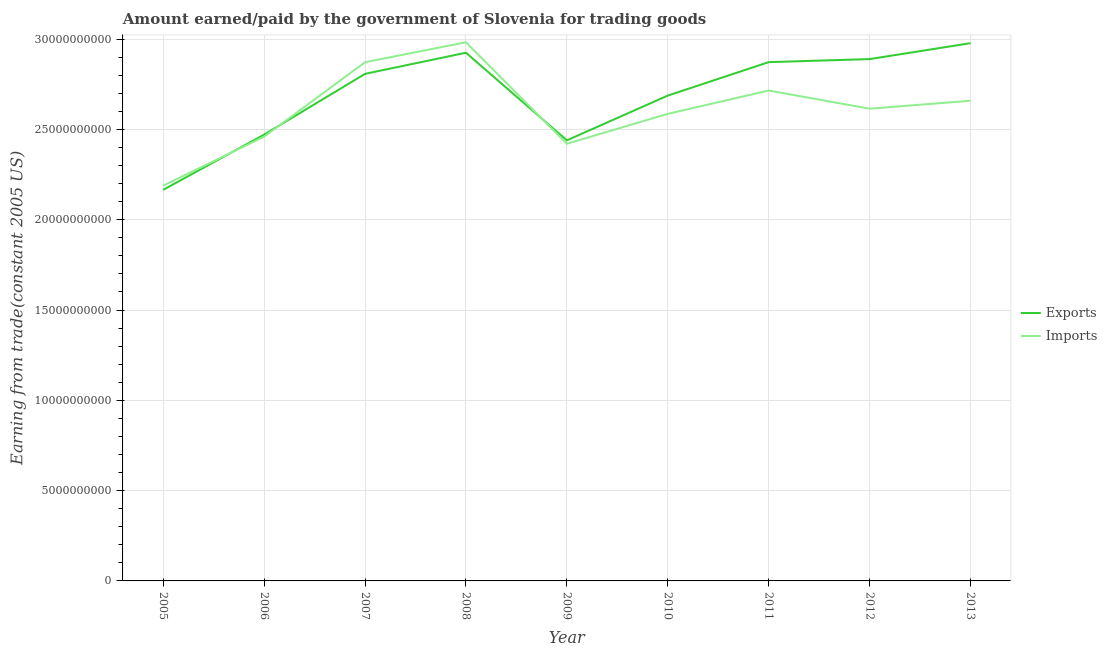What is the amount earned from exports in 2012?
Make the answer very short. 2.89e+1. Across all years, what is the maximum amount earned from exports?
Your response must be concise. 2.98e+1. Across all years, what is the minimum amount paid for imports?
Your response must be concise. 2.19e+1. In which year was the amount paid for imports maximum?
Give a very brief answer. 2008. What is the total amount earned from exports in the graph?
Keep it short and to the point. 2.42e+11. What is the difference between the amount paid for imports in 2007 and that in 2010?
Make the answer very short. 2.86e+09. What is the difference between the amount paid for imports in 2006 and the amount earned from exports in 2008?
Provide a short and direct response. -4.65e+09. What is the average amount paid for imports per year?
Keep it short and to the point. 2.61e+1. In the year 2012, what is the difference between the amount paid for imports and amount earned from exports?
Keep it short and to the point. -2.75e+09. In how many years, is the amount earned from exports greater than 8000000000 US$?
Give a very brief answer. 9. What is the ratio of the amount paid for imports in 2008 to that in 2009?
Your answer should be compact. 1.23. Is the difference between the amount earned from exports in 2008 and 2011 greater than the difference between the amount paid for imports in 2008 and 2011?
Offer a very short reply. No. What is the difference between the highest and the second highest amount earned from exports?
Your response must be concise. 5.29e+08. What is the difference between the highest and the lowest amount paid for imports?
Your answer should be very brief. 7.94e+09. In how many years, is the amount earned from exports greater than the average amount earned from exports taken over all years?
Your response must be concise. 5. Is the sum of the amount paid for imports in 2009 and 2012 greater than the maximum amount earned from exports across all years?
Your response must be concise. Yes. Is the amount paid for imports strictly greater than the amount earned from exports over the years?
Keep it short and to the point. No. How many lines are there?
Provide a short and direct response. 2. How many years are there in the graph?
Offer a terse response. 9. What is the difference between two consecutive major ticks on the Y-axis?
Ensure brevity in your answer.  5.00e+09. Does the graph contain grids?
Provide a short and direct response. Yes. What is the title of the graph?
Offer a terse response. Amount earned/paid by the government of Slovenia for trading goods. What is the label or title of the X-axis?
Keep it short and to the point. Year. What is the label or title of the Y-axis?
Ensure brevity in your answer.  Earning from trade(constant 2005 US). What is the Earning from trade(constant 2005 US) of Exports in 2005?
Make the answer very short. 2.17e+1. What is the Earning from trade(constant 2005 US) in Imports in 2005?
Ensure brevity in your answer.  2.19e+1. What is the Earning from trade(constant 2005 US) of Exports in 2006?
Give a very brief answer. 2.47e+1. What is the Earning from trade(constant 2005 US) of Imports in 2006?
Offer a terse response. 2.46e+1. What is the Earning from trade(constant 2005 US) in Exports in 2007?
Make the answer very short. 2.81e+1. What is the Earning from trade(constant 2005 US) in Imports in 2007?
Give a very brief answer. 2.87e+1. What is the Earning from trade(constant 2005 US) in Exports in 2008?
Make the answer very short. 2.92e+1. What is the Earning from trade(constant 2005 US) of Imports in 2008?
Provide a short and direct response. 2.98e+1. What is the Earning from trade(constant 2005 US) of Exports in 2009?
Your answer should be very brief. 2.44e+1. What is the Earning from trade(constant 2005 US) of Imports in 2009?
Your answer should be compact. 2.42e+1. What is the Earning from trade(constant 2005 US) in Exports in 2010?
Offer a terse response. 2.69e+1. What is the Earning from trade(constant 2005 US) of Imports in 2010?
Offer a terse response. 2.59e+1. What is the Earning from trade(constant 2005 US) in Exports in 2011?
Your answer should be compact. 2.87e+1. What is the Earning from trade(constant 2005 US) of Imports in 2011?
Ensure brevity in your answer.  2.72e+1. What is the Earning from trade(constant 2005 US) in Exports in 2012?
Offer a very short reply. 2.89e+1. What is the Earning from trade(constant 2005 US) in Imports in 2012?
Offer a very short reply. 2.61e+1. What is the Earning from trade(constant 2005 US) in Exports in 2013?
Your answer should be very brief. 2.98e+1. What is the Earning from trade(constant 2005 US) of Imports in 2013?
Offer a very short reply. 2.66e+1. Across all years, what is the maximum Earning from trade(constant 2005 US) of Exports?
Your response must be concise. 2.98e+1. Across all years, what is the maximum Earning from trade(constant 2005 US) in Imports?
Give a very brief answer. 2.98e+1. Across all years, what is the minimum Earning from trade(constant 2005 US) in Exports?
Keep it short and to the point. 2.17e+1. Across all years, what is the minimum Earning from trade(constant 2005 US) of Imports?
Provide a succinct answer. 2.19e+1. What is the total Earning from trade(constant 2005 US) of Exports in the graph?
Your answer should be very brief. 2.42e+11. What is the total Earning from trade(constant 2005 US) in Imports in the graph?
Provide a succinct answer. 2.35e+11. What is the difference between the Earning from trade(constant 2005 US) of Exports in 2005 and that in 2006?
Ensure brevity in your answer.  -3.06e+09. What is the difference between the Earning from trade(constant 2005 US) in Imports in 2005 and that in 2006?
Offer a terse response. -2.71e+09. What is the difference between the Earning from trade(constant 2005 US) in Exports in 2005 and that in 2007?
Your answer should be very brief. -6.42e+09. What is the difference between the Earning from trade(constant 2005 US) in Imports in 2005 and that in 2007?
Your response must be concise. -6.83e+09. What is the difference between the Earning from trade(constant 2005 US) of Exports in 2005 and that in 2008?
Your answer should be very brief. -7.59e+09. What is the difference between the Earning from trade(constant 2005 US) of Imports in 2005 and that in 2008?
Keep it short and to the point. -7.94e+09. What is the difference between the Earning from trade(constant 2005 US) of Exports in 2005 and that in 2009?
Provide a short and direct response. -2.74e+09. What is the difference between the Earning from trade(constant 2005 US) of Imports in 2005 and that in 2009?
Make the answer very short. -2.32e+09. What is the difference between the Earning from trade(constant 2005 US) in Exports in 2005 and that in 2010?
Provide a succinct answer. -5.22e+09. What is the difference between the Earning from trade(constant 2005 US) in Imports in 2005 and that in 2010?
Offer a very short reply. -3.97e+09. What is the difference between the Earning from trade(constant 2005 US) of Exports in 2005 and that in 2011?
Offer a terse response. -7.07e+09. What is the difference between the Earning from trade(constant 2005 US) in Imports in 2005 and that in 2011?
Your answer should be compact. -5.27e+09. What is the difference between the Earning from trade(constant 2005 US) in Exports in 2005 and that in 2012?
Your response must be concise. -7.24e+09. What is the difference between the Earning from trade(constant 2005 US) of Imports in 2005 and that in 2012?
Keep it short and to the point. -4.26e+09. What is the difference between the Earning from trade(constant 2005 US) of Exports in 2005 and that in 2013?
Provide a succinct answer. -8.12e+09. What is the difference between the Earning from trade(constant 2005 US) of Imports in 2005 and that in 2013?
Ensure brevity in your answer.  -4.70e+09. What is the difference between the Earning from trade(constant 2005 US) in Exports in 2006 and that in 2007?
Your response must be concise. -3.36e+09. What is the difference between the Earning from trade(constant 2005 US) in Imports in 2006 and that in 2007?
Offer a terse response. -4.12e+09. What is the difference between the Earning from trade(constant 2005 US) in Exports in 2006 and that in 2008?
Keep it short and to the point. -4.53e+09. What is the difference between the Earning from trade(constant 2005 US) in Imports in 2006 and that in 2008?
Provide a succinct answer. -5.23e+09. What is the difference between the Earning from trade(constant 2005 US) in Exports in 2006 and that in 2009?
Provide a short and direct response. 3.18e+08. What is the difference between the Earning from trade(constant 2005 US) of Imports in 2006 and that in 2009?
Give a very brief answer. 3.92e+08. What is the difference between the Earning from trade(constant 2005 US) in Exports in 2006 and that in 2010?
Ensure brevity in your answer.  -2.16e+09. What is the difference between the Earning from trade(constant 2005 US) in Imports in 2006 and that in 2010?
Give a very brief answer. -1.26e+09. What is the difference between the Earning from trade(constant 2005 US) of Exports in 2006 and that in 2011?
Your response must be concise. -4.01e+09. What is the difference between the Earning from trade(constant 2005 US) in Imports in 2006 and that in 2011?
Your answer should be very brief. -2.56e+09. What is the difference between the Earning from trade(constant 2005 US) of Exports in 2006 and that in 2012?
Provide a short and direct response. -4.18e+09. What is the difference between the Earning from trade(constant 2005 US) in Imports in 2006 and that in 2012?
Make the answer very short. -1.55e+09. What is the difference between the Earning from trade(constant 2005 US) in Exports in 2006 and that in 2013?
Provide a short and direct response. -5.06e+09. What is the difference between the Earning from trade(constant 2005 US) in Imports in 2006 and that in 2013?
Ensure brevity in your answer.  -1.99e+09. What is the difference between the Earning from trade(constant 2005 US) of Exports in 2007 and that in 2008?
Give a very brief answer. -1.17e+09. What is the difference between the Earning from trade(constant 2005 US) in Imports in 2007 and that in 2008?
Offer a terse response. -1.11e+09. What is the difference between the Earning from trade(constant 2005 US) in Exports in 2007 and that in 2009?
Your answer should be compact. 3.68e+09. What is the difference between the Earning from trade(constant 2005 US) in Imports in 2007 and that in 2009?
Provide a succinct answer. 4.51e+09. What is the difference between the Earning from trade(constant 2005 US) of Exports in 2007 and that in 2010?
Ensure brevity in your answer.  1.20e+09. What is the difference between the Earning from trade(constant 2005 US) of Imports in 2007 and that in 2010?
Give a very brief answer. 2.86e+09. What is the difference between the Earning from trade(constant 2005 US) in Exports in 2007 and that in 2011?
Make the answer very short. -6.49e+08. What is the difference between the Earning from trade(constant 2005 US) in Imports in 2007 and that in 2011?
Make the answer very short. 1.57e+09. What is the difference between the Earning from trade(constant 2005 US) of Exports in 2007 and that in 2012?
Your answer should be compact. -8.17e+08. What is the difference between the Earning from trade(constant 2005 US) of Imports in 2007 and that in 2012?
Make the answer very short. 2.57e+09. What is the difference between the Earning from trade(constant 2005 US) of Exports in 2007 and that in 2013?
Keep it short and to the point. -1.70e+09. What is the difference between the Earning from trade(constant 2005 US) of Imports in 2007 and that in 2013?
Keep it short and to the point. 2.13e+09. What is the difference between the Earning from trade(constant 2005 US) in Exports in 2008 and that in 2009?
Your answer should be compact. 4.85e+09. What is the difference between the Earning from trade(constant 2005 US) of Imports in 2008 and that in 2009?
Offer a very short reply. 5.62e+09. What is the difference between the Earning from trade(constant 2005 US) in Exports in 2008 and that in 2010?
Offer a very short reply. 2.37e+09. What is the difference between the Earning from trade(constant 2005 US) in Imports in 2008 and that in 2010?
Offer a very short reply. 3.96e+09. What is the difference between the Earning from trade(constant 2005 US) in Exports in 2008 and that in 2011?
Provide a succinct answer. 5.21e+08. What is the difference between the Earning from trade(constant 2005 US) in Imports in 2008 and that in 2011?
Provide a short and direct response. 2.67e+09. What is the difference between the Earning from trade(constant 2005 US) in Exports in 2008 and that in 2012?
Keep it short and to the point. 3.53e+08. What is the difference between the Earning from trade(constant 2005 US) in Imports in 2008 and that in 2012?
Give a very brief answer. 3.68e+09. What is the difference between the Earning from trade(constant 2005 US) of Exports in 2008 and that in 2013?
Make the answer very short. -5.29e+08. What is the difference between the Earning from trade(constant 2005 US) in Imports in 2008 and that in 2013?
Your response must be concise. 3.24e+09. What is the difference between the Earning from trade(constant 2005 US) in Exports in 2009 and that in 2010?
Keep it short and to the point. -2.48e+09. What is the difference between the Earning from trade(constant 2005 US) of Imports in 2009 and that in 2010?
Your answer should be very brief. -1.66e+09. What is the difference between the Earning from trade(constant 2005 US) of Exports in 2009 and that in 2011?
Keep it short and to the point. -4.33e+09. What is the difference between the Earning from trade(constant 2005 US) of Imports in 2009 and that in 2011?
Provide a succinct answer. -2.95e+09. What is the difference between the Earning from trade(constant 2005 US) of Exports in 2009 and that in 2012?
Your answer should be very brief. -4.50e+09. What is the difference between the Earning from trade(constant 2005 US) in Imports in 2009 and that in 2012?
Offer a terse response. -1.94e+09. What is the difference between the Earning from trade(constant 2005 US) in Exports in 2009 and that in 2013?
Your answer should be compact. -5.38e+09. What is the difference between the Earning from trade(constant 2005 US) in Imports in 2009 and that in 2013?
Ensure brevity in your answer.  -2.38e+09. What is the difference between the Earning from trade(constant 2005 US) in Exports in 2010 and that in 2011?
Keep it short and to the point. -1.85e+09. What is the difference between the Earning from trade(constant 2005 US) in Imports in 2010 and that in 2011?
Provide a short and direct response. -1.29e+09. What is the difference between the Earning from trade(constant 2005 US) in Exports in 2010 and that in 2012?
Provide a succinct answer. -2.02e+09. What is the difference between the Earning from trade(constant 2005 US) of Imports in 2010 and that in 2012?
Provide a succinct answer. -2.86e+08. What is the difference between the Earning from trade(constant 2005 US) of Exports in 2010 and that in 2013?
Make the answer very short. -2.90e+09. What is the difference between the Earning from trade(constant 2005 US) of Imports in 2010 and that in 2013?
Give a very brief answer. -7.26e+08. What is the difference between the Earning from trade(constant 2005 US) in Exports in 2011 and that in 2012?
Provide a short and direct response. -1.68e+08. What is the difference between the Earning from trade(constant 2005 US) in Imports in 2011 and that in 2012?
Ensure brevity in your answer.  1.01e+09. What is the difference between the Earning from trade(constant 2005 US) of Exports in 2011 and that in 2013?
Give a very brief answer. -1.05e+09. What is the difference between the Earning from trade(constant 2005 US) in Imports in 2011 and that in 2013?
Provide a succinct answer. 5.66e+08. What is the difference between the Earning from trade(constant 2005 US) of Exports in 2012 and that in 2013?
Ensure brevity in your answer.  -8.82e+08. What is the difference between the Earning from trade(constant 2005 US) in Imports in 2012 and that in 2013?
Make the answer very short. -4.40e+08. What is the difference between the Earning from trade(constant 2005 US) in Exports in 2005 and the Earning from trade(constant 2005 US) in Imports in 2006?
Make the answer very short. -2.94e+09. What is the difference between the Earning from trade(constant 2005 US) in Exports in 2005 and the Earning from trade(constant 2005 US) in Imports in 2007?
Your response must be concise. -7.07e+09. What is the difference between the Earning from trade(constant 2005 US) of Exports in 2005 and the Earning from trade(constant 2005 US) of Imports in 2008?
Make the answer very short. -8.17e+09. What is the difference between the Earning from trade(constant 2005 US) in Exports in 2005 and the Earning from trade(constant 2005 US) in Imports in 2009?
Make the answer very short. -2.55e+09. What is the difference between the Earning from trade(constant 2005 US) of Exports in 2005 and the Earning from trade(constant 2005 US) of Imports in 2010?
Keep it short and to the point. -4.21e+09. What is the difference between the Earning from trade(constant 2005 US) of Exports in 2005 and the Earning from trade(constant 2005 US) of Imports in 2011?
Give a very brief answer. -5.50e+09. What is the difference between the Earning from trade(constant 2005 US) in Exports in 2005 and the Earning from trade(constant 2005 US) in Imports in 2012?
Make the answer very short. -4.49e+09. What is the difference between the Earning from trade(constant 2005 US) of Exports in 2005 and the Earning from trade(constant 2005 US) of Imports in 2013?
Make the answer very short. -4.93e+09. What is the difference between the Earning from trade(constant 2005 US) in Exports in 2006 and the Earning from trade(constant 2005 US) in Imports in 2007?
Ensure brevity in your answer.  -4.01e+09. What is the difference between the Earning from trade(constant 2005 US) in Exports in 2006 and the Earning from trade(constant 2005 US) in Imports in 2008?
Keep it short and to the point. -5.11e+09. What is the difference between the Earning from trade(constant 2005 US) in Exports in 2006 and the Earning from trade(constant 2005 US) in Imports in 2009?
Provide a succinct answer. 5.07e+08. What is the difference between the Earning from trade(constant 2005 US) in Exports in 2006 and the Earning from trade(constant 2005 US) in Imports in 2010?
Your answer should be compact. -1.15e+09. What is the difference between the Earning from trade(constant 2005 US) in Exports in 2006 and the Earning from trade(constant 2005 US) in Imports in 2011?
Make the answer very short. -2.44e+09. What is the difference between the Earning from trade(constant 2005 US) in Exports in 2006 and the Earning from trade(constant 2005 US) in Imports in 2012?
Your response must be concise. -1.43e+09. What is the difference between the Earning from trade(constant 2005 US) in Exports in 2006 and the Earning from trade(constant 2005 US) in Imports in 2013?
Keep it short and to the point. -1.87e+09. What is the difference between the Earning from trade(constant 2005 US) of Exports in 2007 and the Earning from trade(constant 2005 US) of Imports in 2008?
Offer a very short reply. -1.75e+09. What is the difference between the Earning from trade(constant 2005 US) of Exports in 2007 and the Earning from trade(constant 2005 US) of Imports in 2009?
Give a very brief answer. 3.87e+09. What is the difference between the Earning from trade(constant 2005 US) in Exports in 2007 and the Earning from trade(constant 2005 US) in Imports in 2010?
Your answer should be compact. 2.22e+09. What is the difference between the Earning from trade(constant 2005 US) in Exports in 2007 and the Earning from trade(constant 2005 US) in Imports in 2011?
Offer a very short reply. 9.23e+08. What is the difference between the Earning from trade(constant 2005 US) in Exports in 2007 and the Earning from trade(constant 2005 US) in Imports in 2012?
Offer a terse response. 1.93e+09. What is the difference between the Earning from trade(constant 2005 US) of Exports in 2007 and the Earning from trade(constant 2005 US) of Imports in 2013?
Ensure brevity in your answer.  1.49e+09. What is the difference between the Earning from trade(constant 2005 US) in Exports in 2008 and the Earning from trade(constant 2005 US) in Imports in 2009?
Your answer should be compact. 5.04e+09. What is the difference between the Earning from trade(constant 2005 US) of Exports in 2008 and the Earning from trade(constant 2005 US) of Imports in 2010?
Your answer should be compact. 3.39e+09. What is the difference between the Earning from trade(constant 2005 US) of Exports in 2008 and the Earning from trade(constant 2005 US) of Imports in 2011?
Make the answer very short. 2.09e+09. What is the difference between the Earning from trade(constant 2005 US) of Exports in 2008 and the Earning from trade(constant 2005 US) of Imports in 2012?
Provide a short and direct response. 3.10e+09. What is the difference between the Earning from trade(constant 2005 US) in Exports in 2008 and the Earning from trade(constant 2005 US) in Imports in 2013?
Your answer should be very brief. 2.66e+09. What is the difference between the Earning from trade(constant 2005 US) of Exports in 2009 and the Earning from trade(constant 2005 US) of Imports in 2010?
Your response must be concise. -1.47e+09. What is the difference between the Earning from trade(constant 2005 US) of Exports in 2009 and the Earning from trade(constant 2005 US) of Imports in 2011?
Your response must be concise. -2.76e+09. What is the difference between the Earning from trade(constant 2005 US) in Exports in 2009 and the Earning from trade(constant 2005 US) in Imports in 2012?
Your answer should be very brief. -1.75e+09. What is the difference between the Earning from trade(constant 2005 US) of Exports in 2009 and the Earning from trade(constant 2005 US) of Imports in 2013?
Make the answer very short. -2.19e+09. What is the difference between the Earning from trade(constant 2005 US) in Exports in 2010 and the Earning from trade(constant 2005 US) in Imports in 2011?
Keep it short and to the point. -2.81e+08. What is the difference between the Earning from trade(constant 2005 US) in Exports in 2010 and the Earning from trade(constant 2005 US) in Imports in 2012?
Provide a short and direct response. 7.25e+08. What is the difference between the Earning from trade(constant 2005 US) in Exports in 2010 and the Earning from trade(constant 2005 US) in Imports in 2013?
Provide a succinct answer. 2.85e+08. What is the difference between the Earning from trade(constant 2005 US) of Exports in 2011 and the Earning from trade(constant 2005 US) of Imports in 2012?
Keep it short and to the point. 2.58e+09. What is the difference between the Earning from trade(constant 2005 US) in Exports in 2011 and the Earning from trade(constant 2005 US) in Imports in 2013?
Keep it short and to the point. 2.14e+09. What is the difference between the Earning from trade(constant 2005 US) of Exports in 2012 and the Earning from trade(constant 2005 US) of Imports in 2013?
Offer a very short reply. 2.31e+09. What is the average Earning from trade(constant 2005 US) in Exports per year?
Make the answer very short. 2.69e+1. What is the average Earning from trade(constant 2005 US) in Imports per year?
Your response must be concise. 2.61e+1. In the year 2005, what is the difference between the Earning from trade(constant 2005 US) in Exports and Earning from trade(constant 2005 US) in Imports?
Offer a very short reply. -2.32e+08. In the year 2006, what is the difference between the Earning from trade(constant 2005 US) of Exports and Earning from trade(constant 2005 US) of Imports?
Your answer should be compact. 1.15e+08. In the year 2007, what is the difference between the Earning from trade(constant 2005 US) of Exports and Earning from trade(constant 2005 US) of Imports?
Keep it short and to the point. -6.44e+08. In the year 2008, what is the difference between the Earning from trade(constant 2005 US) of Exports and Earning from trade(constant 2005 US) of Imports?
Provide a short and direct response. -5.80e+08. In the year 2009, what is the difference between the Earning from trade(constant 2005 US) in Exports and Earning from trade(constant 2005 US) in Imports?
Keep it short and to the point. 1.89e+08. In the year 2010, what is the difference between the Earning from trade(constant 2005 US) in Exports and Earning from trade(constant 2005 US) in Imports?
Give a very brief answer. 1.01e+09. In the year 2011, what is the difference between the Earning from trade(constant 2005 US) in Exports and Earning from trade(constant 2005 US) in Imports?
Keep it short and to the point. 1.57e+09. In the year 2012, what is the difference between the Earning from trade(constant 2005 US) of Exports and Earning from trade(constant 2005 US) of Imports?
Your answer should be very brief. 2.75e+09. In the year 2013, what is the difference between the Earning from trade(constant 2005 US) of Exports and Earning from trade(constant 2005 US) of Imports?
Your response must be concise. 3.19e+09. What is the ratio of the Earning from trade(constant 2005 US) of Exports in 2005 to that in 2006?
Offer a very short reply. 0.88. What is the ratio of the Earning from trade(constant 2005 US) in Imports in 2005 to that in 2006?
Provide a short and direct response. 0.89. What is the ratio of the Earning from trade(constant 2005 US) in Exports in 2005 to that in 2007?
Keep it short and to the point. 0.77. What is the ratio of the Earning from trade(constant 2005 US) in Imports in 2005 to that in 2007?
Provide a short and direct response. 0.76. What is the ratio of the Earning from trade(constant 2005 US) in Exports in 2005 to that in 2008?
Your answer should be compact. 0.74. What is the ratio of the Earning from trade(constant 2005 US) of Imports in 2005 to that in 2008?
Your answer should be very brief. 0.73. What is the ratio of the Earning from trade(constant 2005 US) in Exports in 2005 to that in 2009?
Your answer should be compact. 0.89. What is the ratio of the Earning from trade(constant 2005 US) in Imports in 2005 to that in 2009?
Your answer should be very brief. 0.9. What is the ratio of the Earning from trade(constant 2005 US) in Exports in 2005 to that in 2010?
Make the answer very short. 0.81. What is the ratio of the Earning from trade(constant 2005 US) of Imports in 2005 to that in 2010?
Provide a succinct answer. 0.85. What is the ratio of the Earning from trade(constant 2005 US) of Exports in 2005 to that in 2011?
Make the answer very short. 0.75. What is the ratio of the Earning from trade(constant 2005 US) in Imports in 2005 to that in 2011?
Make the answer very short. 0.81. What is the ratio of the Earning from trade(constant 2005 US) in Exports in 2005 to that in 2012?
Keep it short and to the point. 0.75. What is the ratio of the Earning from trade(constant 2005 US) in Imports in 2005 to that in 2012?
Offer a very short reply. 0.84. What is the ratio of the Earning from trade(constant 2005 US) in Exports in 2005 to that in 2013?
Your answer should be compact. 0.73. What is the ratio of the Earning from trade(constant 2005 US) of Imports in 2005 to that in 2013?
Make the answer very short. 0.82. What is the ratio of the Earning from trade(constant 2005 US) in Exports in 2006 to that in 2007?
Keep it short and to the point. 0.88. What is the ratio of the Earning from trade(constant 2005 US) in Imports in 2006 to that in 2007?
Offer a terse response. 0.86. What is the ratio of the Earning from trade(constant 2005 US) in Exports in 2006 to that in 2008?
Keep it short and to the point. 0.84. What is the ratio of the Earning from trade(constant 2005 US) of Imports in 2006 to that in 2008?
Provide a succinct answer. 0.82. What is the ratio of the Earning from trade(constant 2005 US) in Exports in 2006 to that in 2009?
Make the answer very short. 1.01. What is the ratio of the Earning from trade(constant 2005 US) in Imports in 2006 to that in 2009?
Your response must be concise. 1.02. What is the ratio of the Earning from trade(constant 2005 US) in Exports in 2006 to that in 2010?
Provide a short and direct response. 0.92. What is the ratio of the Earning from trade(constant 2005 US) of Imports in 2006 to that in 2010?
Your answer should be very brief. 0.95. What is the ratio of the Earning from trade(constant 2005 US) in Exports in 2006 to that in 2011?
Provide a short and direct response. 0.86. What is the ratio of the Earning from trade(constant 2005 US) in Imports in 2006 to that in 2011?
Provide a short and direct response. 0.91. What is the ratio of the Earning from trade(constant 2005 US) in Exports in 2006 to that in 2012?
Provide a succinct answer. 0.86. What is the ratio of the Earning from trade(constant 2005 US) in Imports in 2006 to that in 2012?
Offer a terse response. 0.94. What is the ratio of the Earning from trade(constant 2005 US) in Exports in 2006 to that in 2013?
Your response must be concise. 0.83. What is the ratio of the Earning from trade(constant 2005 US) in Imports in 2006 to that in 2013?
Provide a succinct answer. 0.93. What is the ratio of the Earning from trade(constant 2005 US) in Exports in 2007 to that in 2008?
Offer a very short reply. 0.96. What is the ratio of the Earning from trade(constant 2005 US) in Imports in 2007 to that in 2008?
Your answer should be very brief. 0.96. What is the ratio of the Earning from trade(constant 2005 US) of Exports in 2007 to that in 2009?
Keep it short and to the point. 1.15. What is the ratio of the Earning from trade(constant 2005 US) of Imports in 2007 to that in 2009?
Ensure brevity in your answer.  1.19. What is the ratio of the Earning from trade(constant 2005 US) in Exports in 2007 to that in 2010?
Keep it short and to the point. 1.04. What is the ratio of the Earning from trade(constant 2005 US) of Imports in 2007 to that in 2010?
Give a very brief answer. 1.11. What is the ratio of the Earning from trade(constant 2005 US) of Exports in 2007 to that in 2011?
Offer a terse response. 0.98. What is the ratio of the Earning from trade(constant 2005 US) of Imports in 2007 to that in 2011?
Make the answer very short. 1.06. What is the ratio of the Earning from trade(constant 2005 US) of Exports in 2007 to that in 2012?
Make the answer very short. 0.97. What is the ratio of the Earning from trade(constant 2005 US) of Imports in 2007 to that in 2012?
Give a very brief answer. 1.1. What is the ratio of the Earning from trade(constant 2005 US) in Exports in 2007 to that in 2013?
Ensure brevity in your answer.  0.94. What is the ratio of the Earning from trade(constant 2005 US) of Imports in 2007 to that in 2013?
Give a very brief answer. 1.08. What is the ratio of the Earning from trade(constant 2005 US) in Exports in 2008 to that in 2009?
Offer a terse response. 1.2. What is the ratio of the Earning from trade(constant 2005 US) of Imports in 2008 to that in 2009?
Your answer should be compact. 1.23. What is the ratio of the Earning from trade(constant 2005 US) of Exports in 2008 to that in 2010?
Offer a very short reply. 1.09. What is the ratio of the Earning from trade(constant 2005 US) of Imports in 2008 to that in 2010?
Your response must be concise. 1.15. What is the ratio of the Earning from trade(constant 2005 US) of Exports in 2008 to that in 2011?
Your answer should be compact. 1.02. What is the ratio of the Earning from trade(constant 2005 US) of Imports in 2008 to that in 2011?
Offer a very short reply. 1.1. What is the ratio of the Earning from trade(constant 2005 US) of Exports in 2008 to that in 2012?
Your answer should be compact. 1.01. What is the ratio of the Earning from trade(constant 2005 US) of Imports in 2008 to that in 2012?
Provide a succinct answer. 1.14. What is the ratio of the Earning from trade(constant 2005 US) in Exports in 2008 to that in 2013?
Your answer should be very brief. 0.98. What is the ratio of the Earning from trade(constant 2005 US) of Imports in 2008 to that in 2013?
Keep it short and to the point. 1.12. What is the ratio of the Earning from trade(constant 2005 US) of Exports in 2009 to that in 2010?
Make the answer very short. 0.91. What is the ratio of the Earning from trade(constant 2005 US) in Imports in 2009 to that in 2010?
Your response must be concise. 0.94. What is the ratio of the Earning from trade(constant 2005 US) of Exports in 2009 to that in 2011?
Offer a very short reply. 0.85. What is the ratio of the Earning from trade(constant 2005 US) of Imports in 2009 to that in 2011?
Provide a short and direct response. 0.89. What is the ratio of the Earning from trade(constant 2005 US) in Exports in 2009 to that in 2012?
Provide a succinct answer. 0.84. What is the ratio of the Earning from trade(constant 2005 US) in Imports in 2009 to that in 2012?
Give a very brief answer. 0.93. What is the ratio of the Earning from trade(constant 2005 US) of Exports in 2009 to that in 2013?
Provide a succinct answer. 0.82. What is the ratio of the Earning from trade(constant 2005 US) in Imports in 2009 to that in 2013?
Keep it short and to the point. 0.91. What is the ratio of the Earning from trade(constant 2005 US) of Exports in 2010 to that in 2011?
Ensure brevity in your answer.  0.94. What is the ratio of the Earning from trade(constant 2005 US) of Exports in 2010 to that in 2012?
Ensure brevity in your answer.  0.93. What is the ratio of the Earning from trade(constant 2005 US) of Exports in 2010 to that in 2013?
Your response must be concise. 0.9. What is the ratio of the Earning from trade(constant 2005 US) in Imports in 2010 to that in 2013?
Provide a succinct answer. 0.97. What is the ratio of the Earning from trade(constant 2005 US) of Exports in 2011 to that in 2012?
Give a very brief answer. 0.99. What is the ratio of the Earning from trade(constant 2005 US) in Imports in 2011 to that in 2012?
Keep it short and to the point. 1.04. What is the ratio of the Earning from trade(constant 2005 US) of Exports in 2011 to that in 2013?
Give a very brief answer. 0.96. What is the ratio of the Earning from trade(constant 2005 US) in Imports in 2011 to that in 2013?
Provide a succinct answer. 1.02. What is the ratio of the Earning from trade(constant 2005 US) of Exports in 2012 to that in 2013?
Make the answer very short. 0.97. What is the ratio of the Earning from trade(constant 2005 US) of Imports in 2012 to that in 2013?
Your answer should be very brief. 0.98. What is the difference between the highest and the second highest Earning from trade(constant 2005 US) in Exports?
Ensure brevity in your answer.  5.29e+08. What is the difference between the highest and the second highest Earning from trade(constant 2005 US) of Imports?
Provide a short and direct response. 1.11e+09. What is the difference between the highest and the lowest Earning from trade(constant 2005 US) in Exports?
Your response must be concise. 8.12e+09. What is the difference between the highest and the lowest Earning from trade(constant 2005 US) of Imports?
Ensure brevity in your answer.  7.94e+09. 